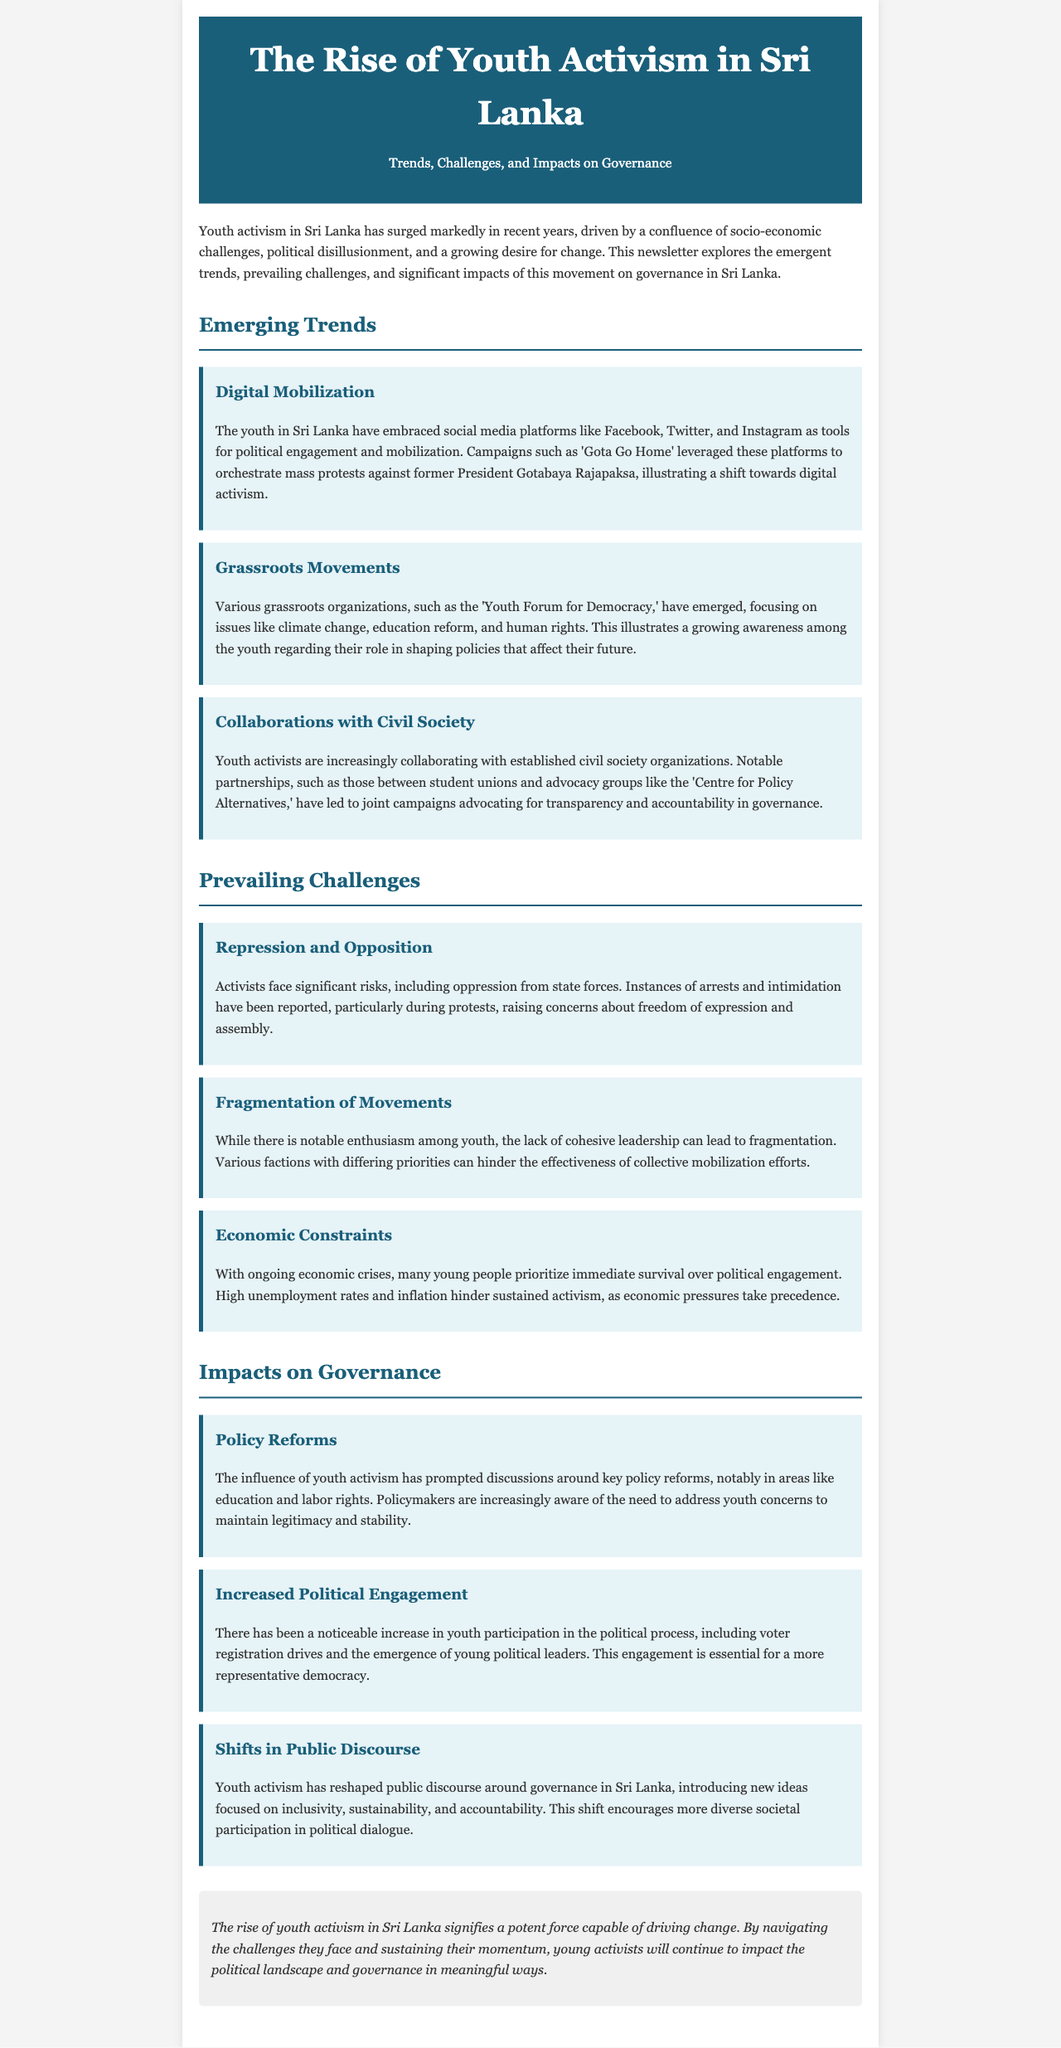What are the main social media platforms used for mobilization? The document states that the youth in Sri Lanka have embraced platforms like Facebook, Twitter, and Instagram for political engagement and mobilization.
Answer: Facebook, Twitter, Instagram What grassroots organization focuses on climate change, education reform, and human rights? The 'Youth Forum for Democracy' is mentioned as an organization focusing on these critical issues.
Answer: Youth Forum for Democracy What significant risk do activists face during protests? The document highlights that activists face repression, with reports of arrests and intimidation during protests.
Answer: Repression What is a challenge associated with the enthusiasm among youth activists? The lack of cohesive leadership leading to fragmentation of movements is noted as a challenge in the document.
Answer: Fragmentation Which area has seen discussions around policy reforms influenced by youth activism? The document specifically mentions discussions around education and labor rights as impacted areas.
Answer: Education, labor rights What phenomenon has led to increased political engagement among youth? The document indicates that there has been a noticeable increase in youth participation in the political process, including voter registration.
Answer: Increased political engagement What impact of youth activism has reshaped public discourse? Youth activism has introduced new ideas focused on inclusivity, sustainability, and accountability, reshaping public discourse.
Answer: Shifts in public discourse What is the conclusion about the rise of youth activism in Sri Lanka? The concluding remarks suggest that youth activism signifies a potent force capable of driving change in the political landscape.
Answer: Potent force driving change 